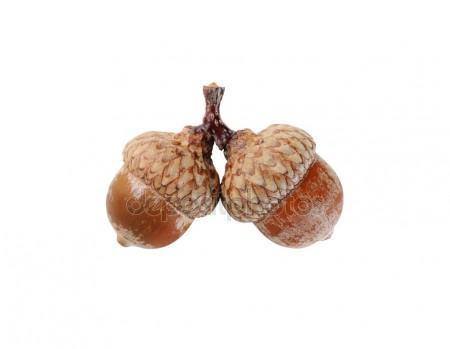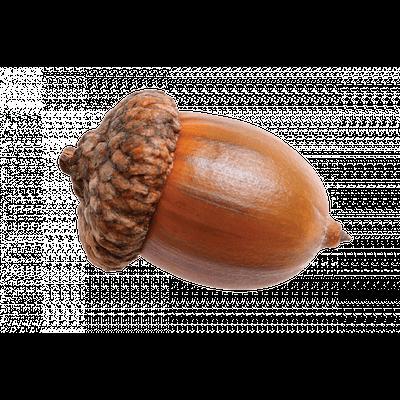The first image is the image on the left, the second image is the image on the right. Considering the images on both sides, is "There are four acorns in total." valid? Answer yes or no. No. 